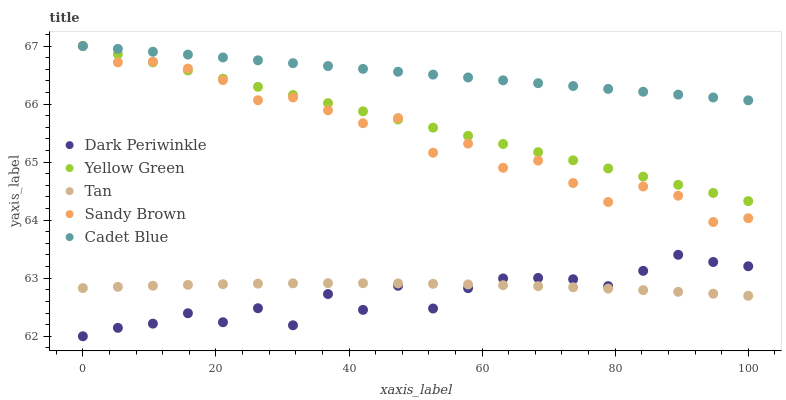Does Dark Periwinkle have the minimum area under the curve?
Answer yes or no. Yes. Does Cadet Blue have the maximum area under the curve?
Answer yes or no. Yes. Does Sandy Brown have the minimum area under the curve?
Answer yes or no. No. Does Sandy Brown have the maximum area under the curve?
Answer yes or no. No. Is Cadet Blue the smoothest?
Answer yes or no. Yes. Is Dark Periwinkle the roughest?
Answer yes or no. Yes. Is Sandy Brown the smoothest?
Answer yes or no. No. Is Sandy Brown the roughest?
Answer yes or no. No. Does Dark Periwinkle have the lowest value?
Answer yes or no. Yes. Does Sandy Brown have the lowest value?
Answer yes or no. No. Does Yellow Green have the highest value?
Answer yes or no. Yes. Does Dark Periwinkle have the highest value?
Answer yes or no. No. Is Dark Periwinkle less than Yellow Green?
Answer yes or no. Yes. Is Sandy Brown greater than Dark Periwinkle?
Answer yes or no. Yes. Does Tan intersect Dark Periwinkle?
Answer yes or no. Yes. Is Tan less than Dark Periwinkle?
Answer yes or no. No. Is Tan greater than Dark Periwinkle?
Answer yes or no. No. Does Dark Periwinkle intersect Yellow Green?
Answer yes or no. No. 